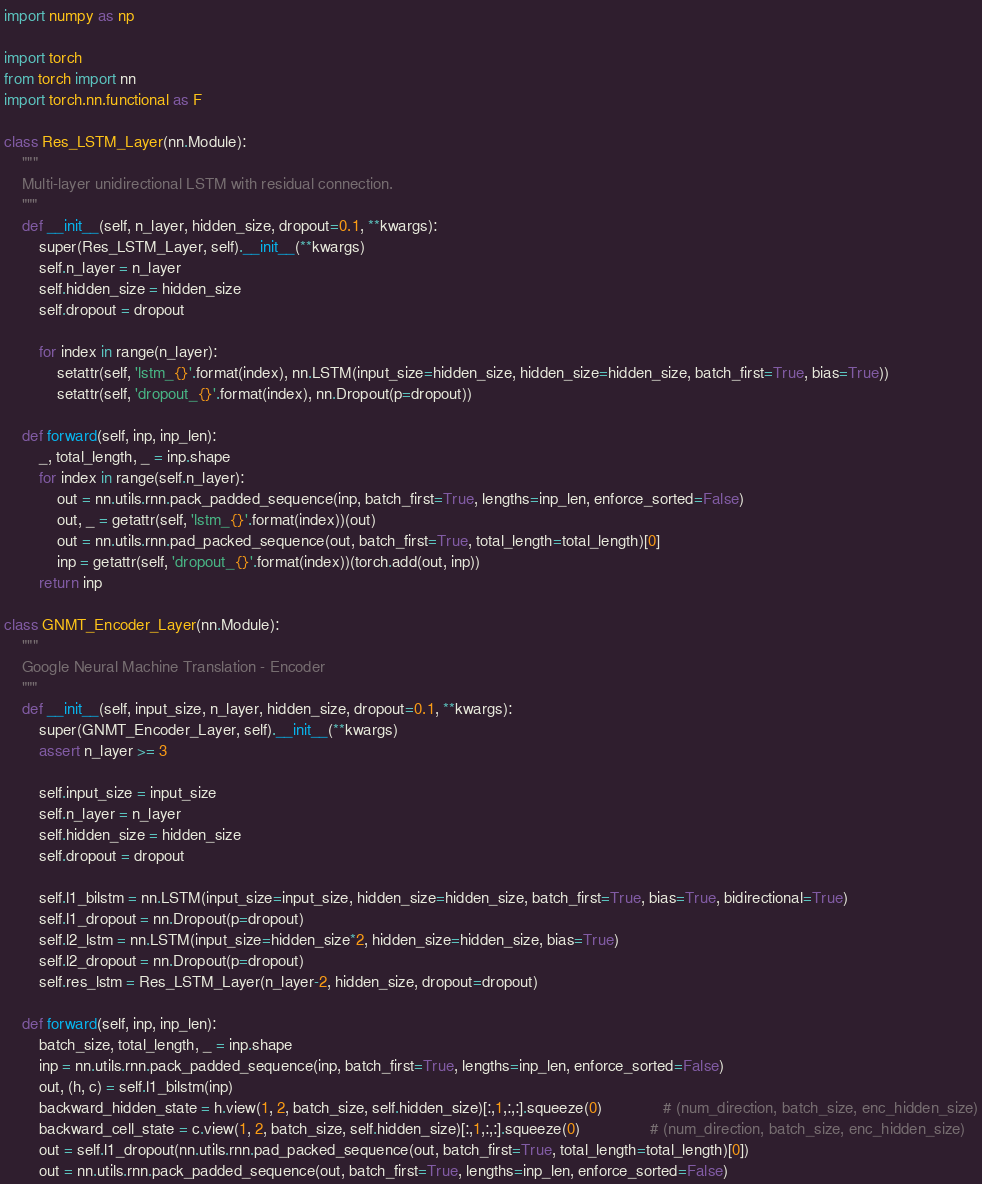<code> <loc_0><loc_0><loc_500><loc_500><_Python_>import numpy as np

import torch
from torch import nn
import torch.nn.functional as F

class Res_LSTM_Layer(nn.Module):
	"""
	Multi-layer unidirectional LSTM with residual connection.
	"""
	def __init__(self, n_layer, hidden_size, dropout=0.1, **kwargs):
		super(Res_LSTM_Layer, self).__init__(**kwargs)
		self.n_layer = n_layer
		self.hidden_size = hidden_size
		self.dropout = dropout

		for index in range(n_layer):
			setattr(self, 'lstm_{}'.format(index), nn.LSTM(input_size=hidden_size, hidden_size=hidden_size, batch_first=True, bias=True))
			setattr(self, 'dropout_{}'.format(index), nn.Dropout(p=dropout))

	def forward(self, inp, inp_len):
		_, total_length, _ = inp.shape
		for index in range(self.n_layer):
			out = nn.utils.rnn.pack_padded_sequence(inp, batch_first=True, lengths=inp_len, enforce_sorted=False)
			out, _ = getattr(self, 'lstm_{}'.format(index))(out)
			out = nn.utils.rnn.pad_packed_sequence(out, batch_first=True, total_length=total_length)[0]
			inp = getattr(self, 'dropout_{}'.format(index))(torch.add(out, inp))
		return inp

class GNMT_Encoder_Layer(nn.Module):
	"""
	Google Neural Machine Translation - Encoder
	"""
	def __init__(self, input_size, n_layer, hidden_size, dropout=0.1, **kwargs):
		super(GNMT_Encoder_Layer, self).__init__(**kwargs)
		assert n_layer >= 3

		self.input_size = input_size
		self.n_layer = n_layer
		self.hidden_size = hidden_size
		self.dropout = dropout

		self.l1_bilstm = nn.LSTM(input_size=input_size, hidden_size=hidden_size, batch_first=True, bias=True, bidirectional=True)
		self.l1_dropout = nn.Dropout(p=dropout)
		self.l2_lstm = nn.LSTM(input_size=hidden_size*2, hidden_size=hidden_size, bias=True)
		self.l2_dropout = nn.Dropout(p=dropout)
		self.res_lstm = Res_LSTM_Layer(n_layer-2, hidden_size, dropout=dropout)

	def forward(self, inp, inp_len):
		batch_size, total_length, _ = inp.shape
		inp = nn.utils.rnn.pack_padded_sequence(inp, batch_first=True, lengths=inp_len, enforce_sorted=False)
		out, (h, c) = self.l1_bilstm(inp)
		backward_hidden_state = h.view(1, 2, batch_size, self.hidden_size)[:,1,:,:].squeeze(0)              # (num_direction, batch_size, enc_hidden_size)
		backward_cell_state = c.view(1, 2, batch_size, self.hidden_size)[:,1,:,:].squeeze(0)                # (num_direction, batch_size, enc_hidden_size)
		out = self.l1_dropout(nn.utils.rnn.pad_packed_sequence(out, batch_first=True, total_length=total_length)[0])
		out = nn.utils.rnn.pack_padded_sequence(out, batch_first=True, lengths=inp_len, enforce_sorted=False)</code> 